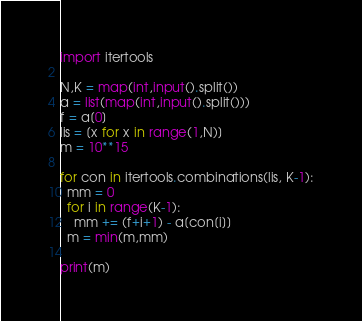<code> <loc_0><loc_0><loc_500><loc_500><_Python_>import itertools

N,K = map(int,input().split())
a = list(map(int,input().split()))
f = a[0]
lis = [x for x in range(1,N)]
m = 10**15

for con in itertools.combinations(lis, K-1):
  mm = 0
  for i in range(K-1):
    mm += (f+i+1) - a[con[i]]
  m = min(m,mm)
  
print(m)</code> 